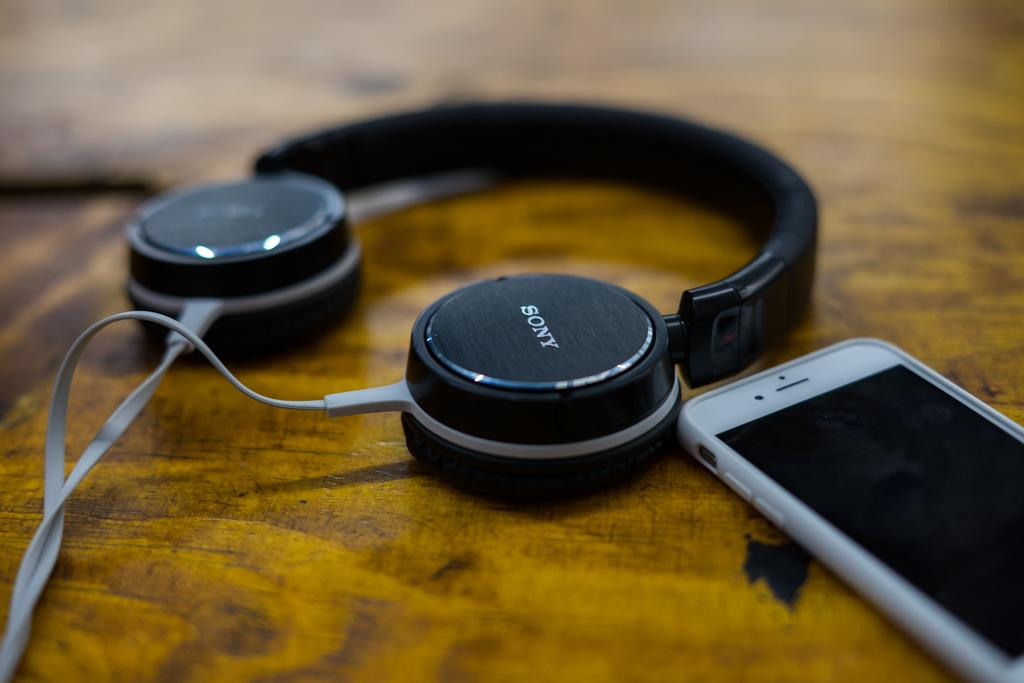What electronic device is visible in the image? There is a mobile in the image. What accessory is also present in the image? There are headphones in the image. Where are the mobile and headphones located? The mobile and headphones are on a platform. Who is wearing the crown in the image? There is no crown present in the image. Is there a baseball game happening in the image? There is no baseball game or any reference to baseball in the image. 